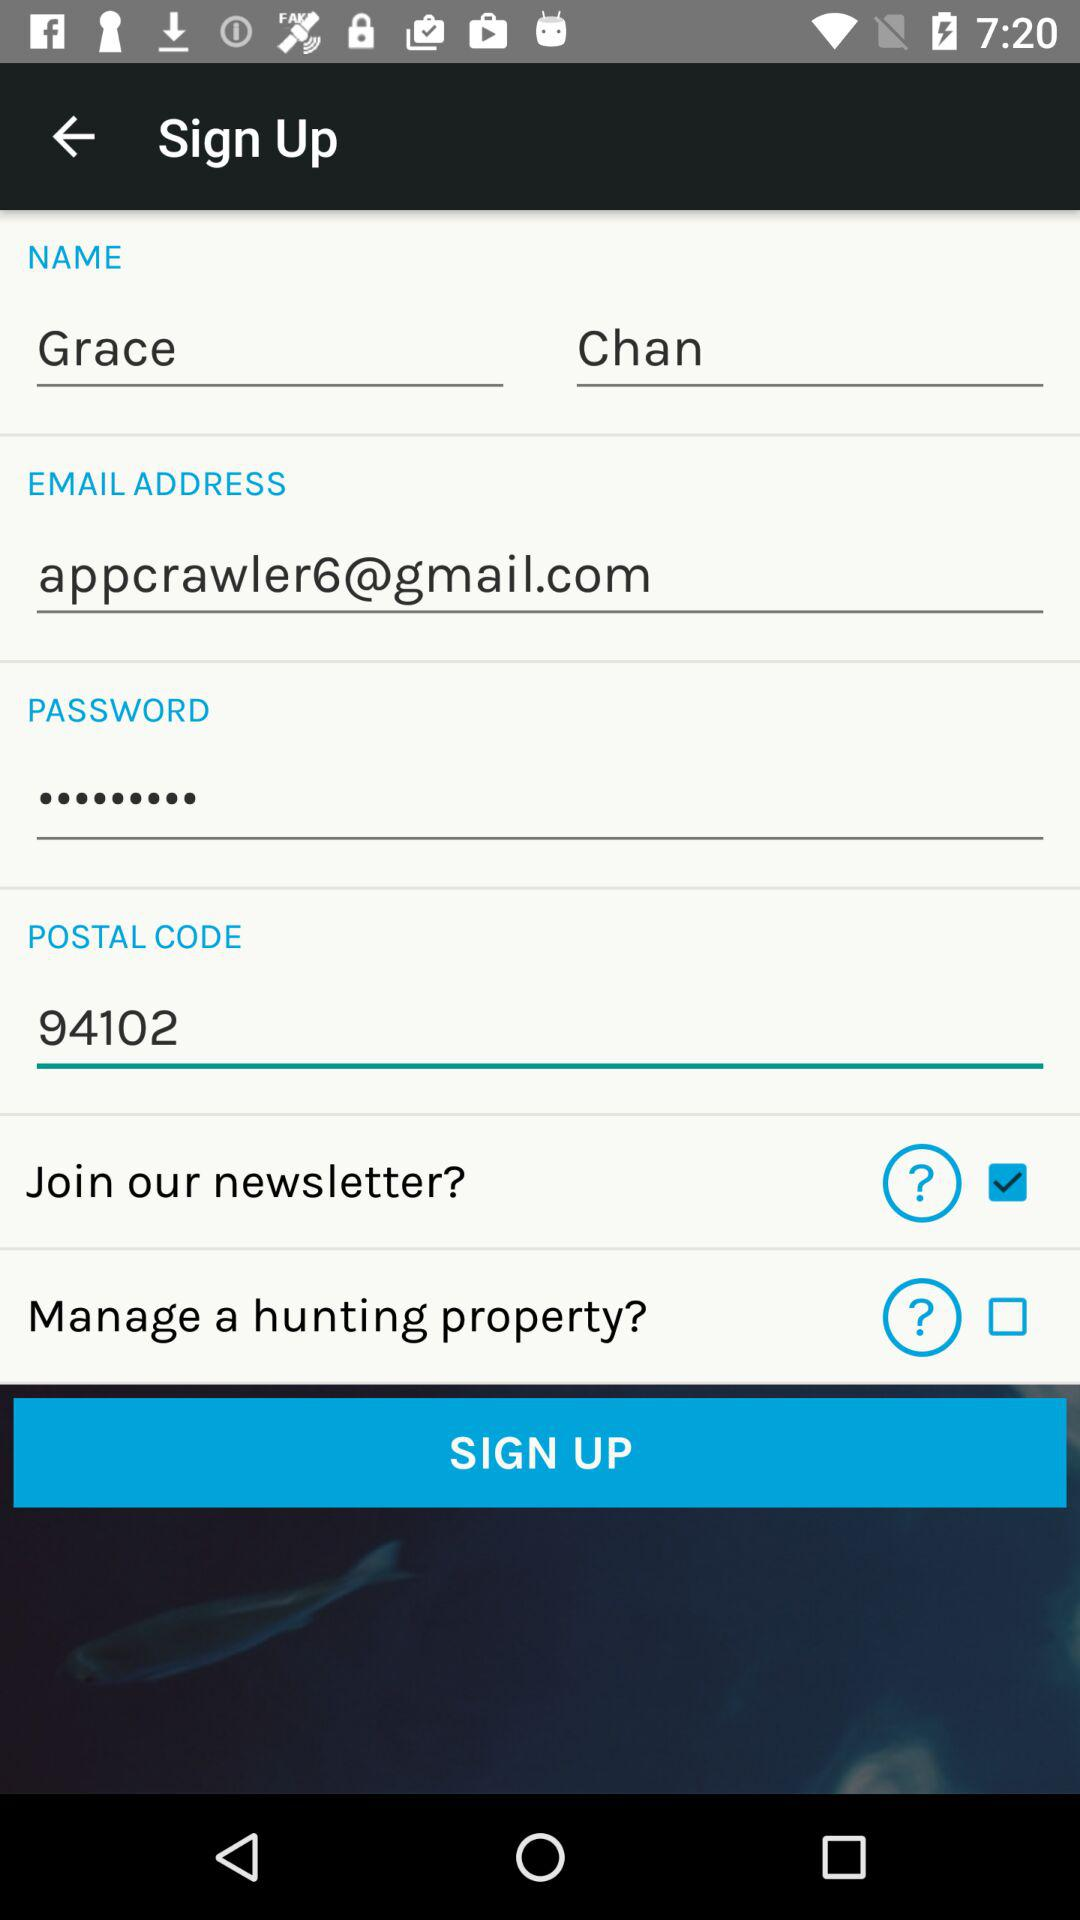Which region has the postal code 94102?
When the provided information is insufficient, respond with <no answer>. <no answer> 